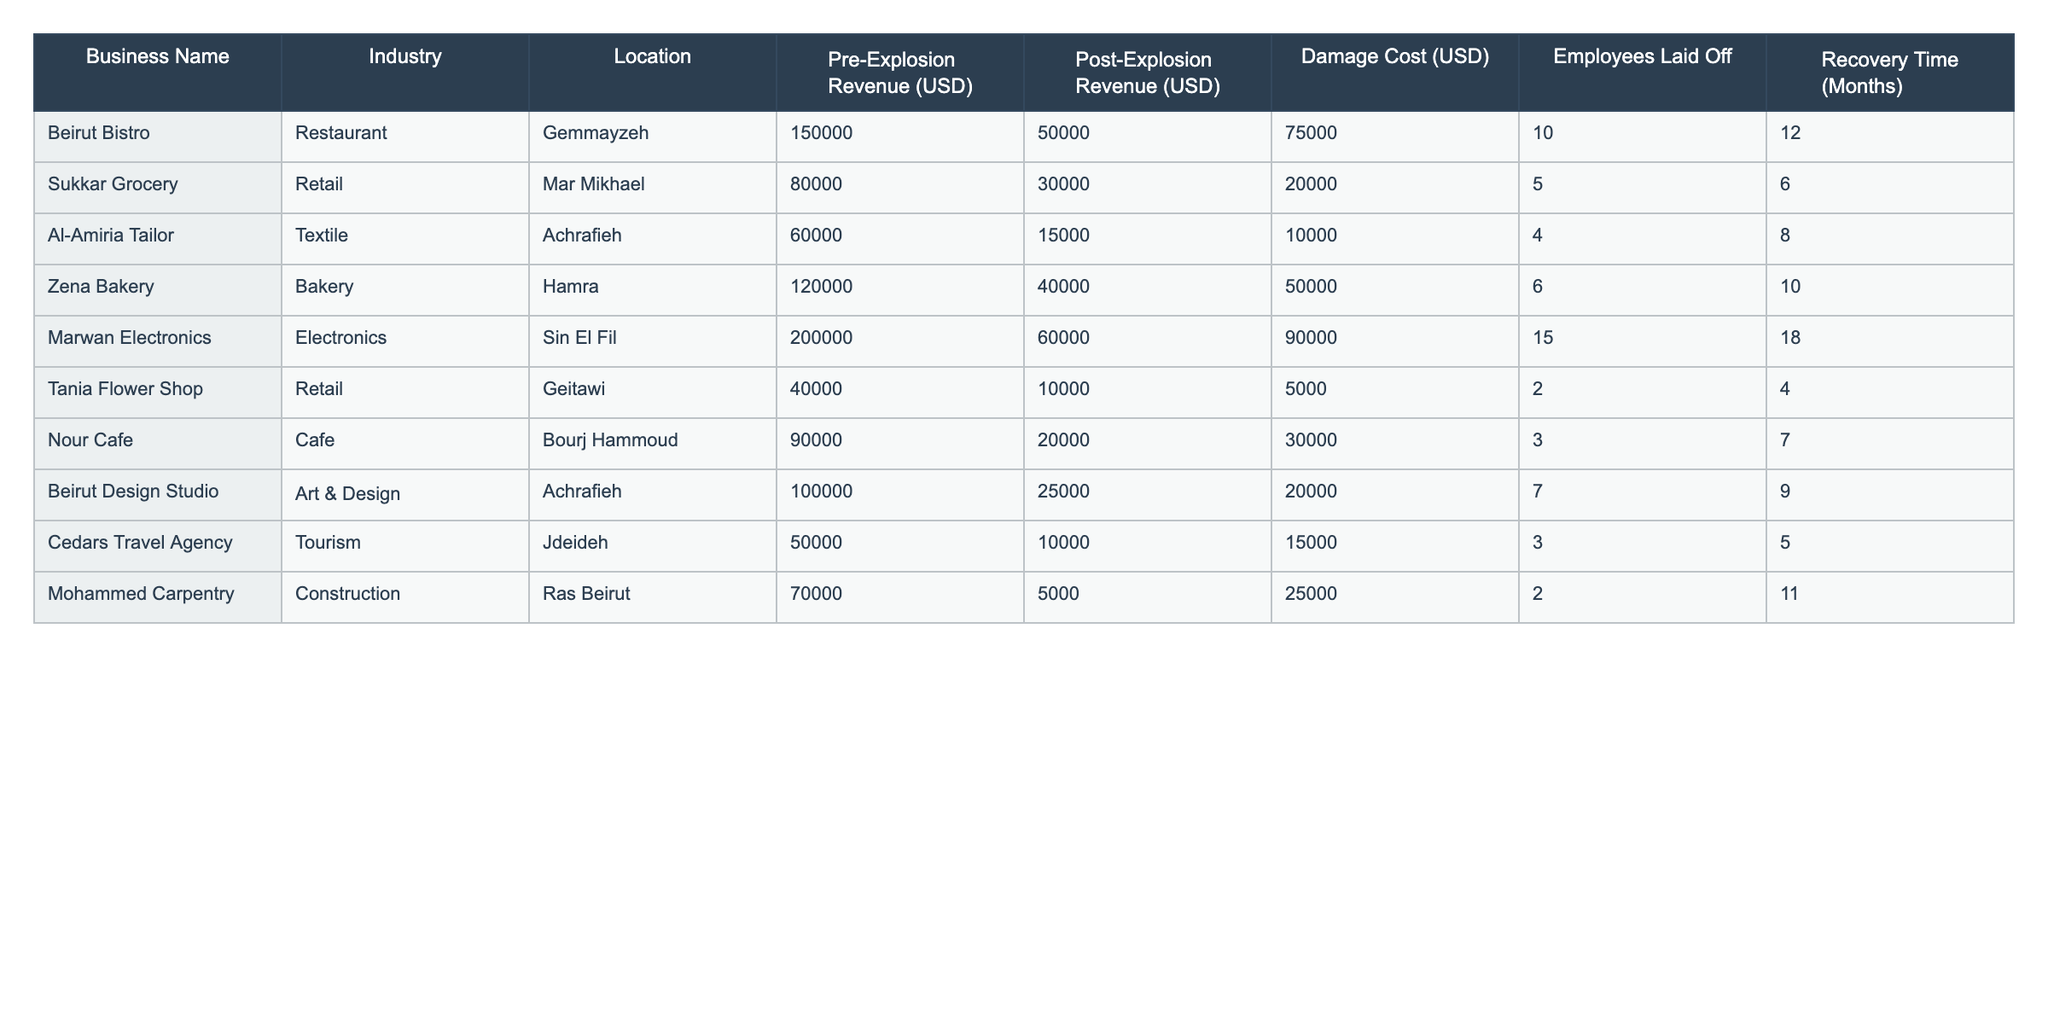What is the business that suffered the highest damage cost? From the table, the damage cost of each business can be compared. Marwan Electronics has the highest damage cost of 90,000 USD.
Answer: Marwan Electronics How many employees were laid off in total across all businesses? By adding the number of employees laid off for each business: 10 + 5 + 4 + 6 + 15 + 2 + 3 + 7 + 3 + 2 = 57 employees were laid off in total.
Answer: 57 Which business had the most significant decrease in revenue after the explosion? The decrease in revenue for each business can be calculated by subtracting post-explosion revenue from pre-explosion revenue. Zena Bakery had a decrease of 80,000 USD (120,000 - 40,000).
Answer: Zena Bakery What is the average recovery time for all the businesses listed? To find the average recovery time, sum the recovery times (12 + 6 + 8 + 10 + 18 + 4 + 7 + 9 + 5 + 11 = 90) and divide by the number of businesses (10), which results in an average recovery time of 9 months.
Answer: 9 months Is there any business that operated in the same industry and experienced similar revenue loss? Comparing the revenue loss between businesses in the same industry reveals that Zena Bakery and Nour Cafe, both in food services, had revenue losses of 80,000 USD and 70,000 USD, respectively, showing that food service businesses faced similar losses.
Answer: Yes What percentage of their pre-explosion revenue did Cedars Travel Agency lose? Cedars Travel Agency had a pre-explosion revenue of 50,000 USD and post-explosion revenue of 10,000 USD. The revenue loss is 40,000 USD. The percentage lost is (40,000 / 50,000) * 100 = 80%.
Answer: 80% Which location has the highest average damage cost among the listed businesses? By calculating the average damage cost for businesses in each location, Sin El Fil has the highest, since Marwan Electronics contributes 90,000 USD alone, while any other location averages less than that.
Answer: Sin El Fil Did any of the businesses in Achrafieh lay off employees after the explosion? Both businesses in Achrafieh, Al-Amiria Tailor and Beirut Design Studio, laid off employees (4 and 7 respectively).
Answer: Yes How many businesses had a recovery time of more than 10 months? By examining the recovery times, Beirut Bistro (12 months), Marwan Electronics (18 months), and Mohammed Carpentry (11 months) had recovery times exceeding 10 months. Thus, 3 businesses fit this criterion.
Answer: 3 businesses What is the difference in revenue between the highest and lowest revenue businesses after the explosion? The highest post-explosion revenue is from Beirut Bistro at 50,000 USD, and the lowest is from Tania Flower Shop at 10,000 USD. The difference is 50,000 - 10,000 = 40,000 USD.
Answer: 40,000 USD 